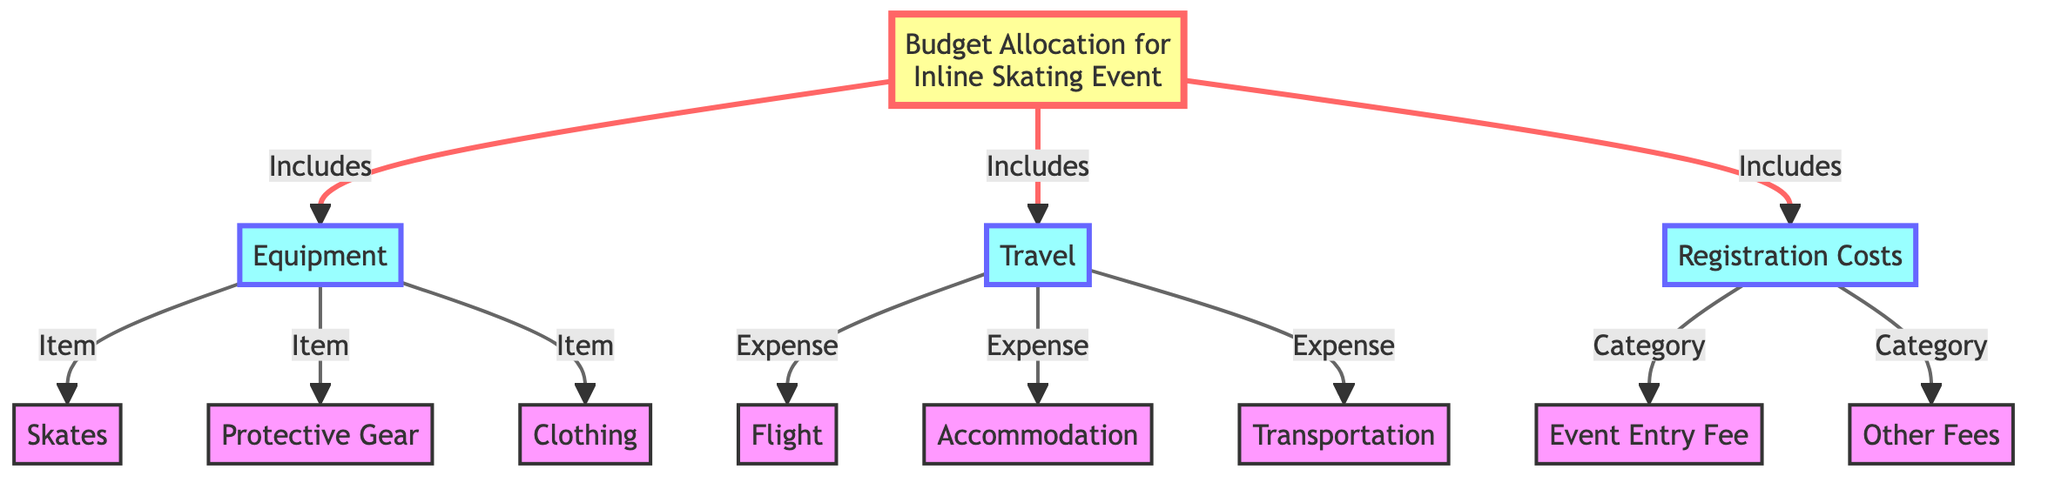What are the main categories included in the budget? The diagram indicates three main categories that are included in the budget: Equipment, Travel, and Registration Costs. These categories are clearly defined as separate elements connected to the central node representing the budget allocation.
Answer: Equipment, Travel, Registration Costs How many items are listed under Equipment? The diagram shows that there are three distinct items listed under the Equipment category: Skates, Protective Gear, and Clothing. Each item is branched off from the Equipment category, thus allowing for an easy count.
Answer: Three Which category does the Event Entry Fee belong to? The diagram specifies that the Event Entry Fee is categorized under Registration Costs, indicated by the structure that shows it as a sub-item stemming from the broader Registration Costs category.
Answer: Registration Costs What type of costs are Flight, Accommodation, and Transportation? Flight, Accommodation, and Transportation are specified as expenses within the Travel category in the diagram. The diagram organizes these items under the main Travel category, which helps identify them as costs related to travel for the event.
Answer: Expenses How many total items are classified under Registration Costs? The diagram lists two items under Registration Costs: Event Entry Fee and Other Fees. Since both of these items are directly connected to the Registration Costs node, we can total them easily.
Answer: Two Which is the first category listed in the diagram? The first category outlined in the diagram is Equipment. It is arranged directly below the main budget allocation node, establishing it as the first category visually.
Answer: Equipment Which sub-item is linked to the Protective Gear item? The diagram does not show any sub-items linked specifically to Protective Gear, indicating that it is a standalone item under the Equipment category. It is not part of a larger list like the Travel or Registration Costs categories, which include multiple linked items.
Answer: None Are there more travel expenses or equipment items listed? The diagram indicates that there are three equipment items (Skates, Protective Gear, Clothing) compared to three travel expenses (Flight, Accommodation, Transportation). Thus, they are equal in number, showing no category has more than the other.
Answer: Equal What type of diagram is represented? This is a flowchart diagram, as indicated by its structure of nodes and connecting lines, which organize the budget allocation into categories and sub-items appealing for educational or analytical purposes.
Answer: Flowchart 